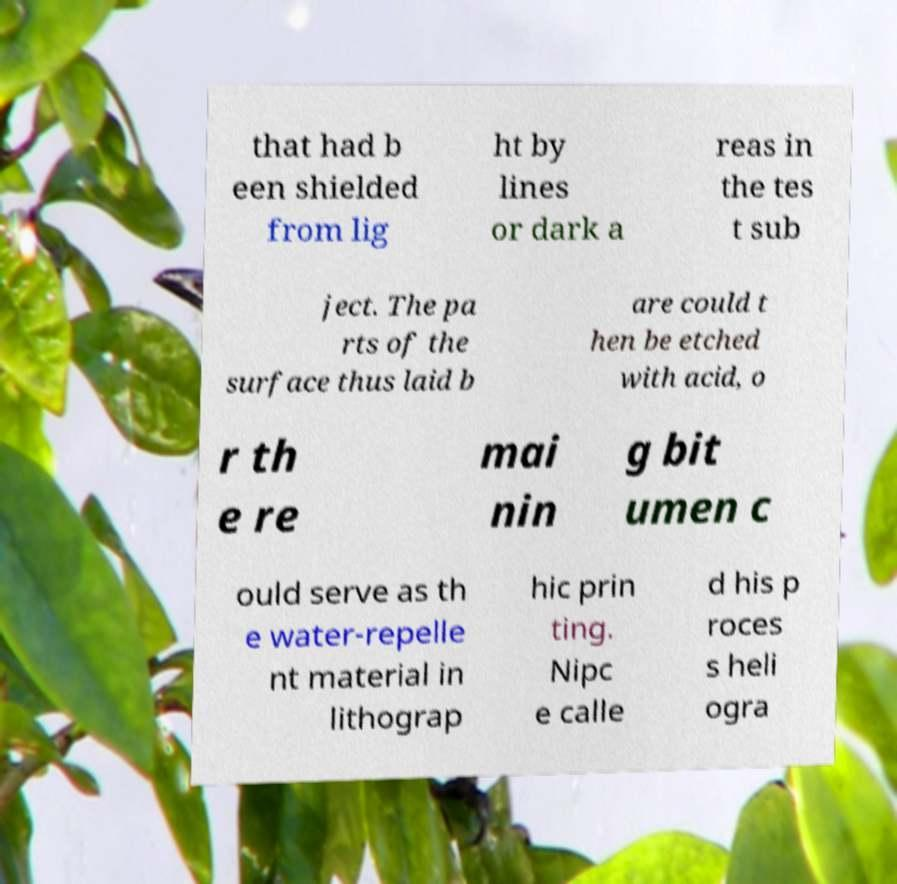Please identify and transcribe the text found in this image. that had b een shielded from lig ht by lines or dark a reas in the tes t sub ject. The pa rts of the surface thus laid b are could t hen be etched with acid, o r th e re mai nin g bit umen c ould serve as th e water-repelle nt material in lithograp hic prin ting. Nipc e calle d his p roces s heli ogra 